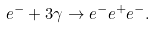Convert formula to latex. <formula><loc_0><loc_0><loc_500><loc_500>e ^ { - } + 3 \gamma \rightarrow e ^ { - } e ^ { + } e ^ { - } .</formula> 